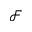<formula> <loc_0><loc_0><loc_500><loc_500>\mathcal { F }</formula> 